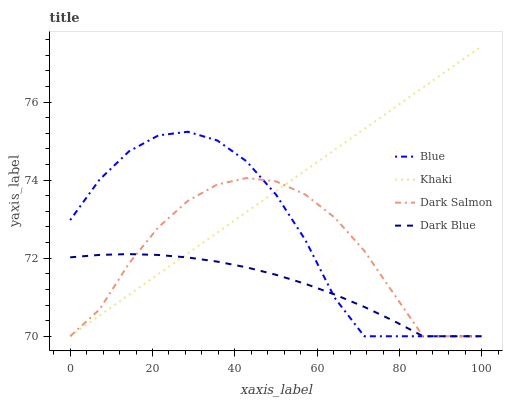Does Dark Blue have the minimum area under the curve?
Answer yes or no. Yes. Does Khaki have the minimum area under the curve?
Answer yes or no. No. Does Dark Blue have the maximum area under the curve?
Answer yes or no. No. Is Khaki the smoothest?
Answer yes or no. Yes. Is Blue the roughest?
Answer yes or no. Yes. Is Dark Blue the smoothest?
Answer yes or no. No. Is Dark Blue the roughest?
Answer yes or no. No. Does Dark Blue have the highest value?
Answer yes or no. No. 